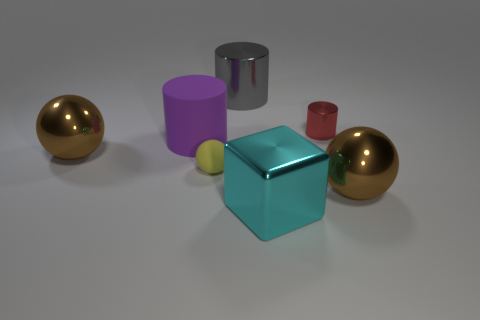There is a shiny object that is right of the tiny cylinder; is its shape the same as the large purple matte object?
Offer a terse response. No. What size is the rubber sphere that is in front of the red metallic thing right of the gray metallic cylinder?
Ensure brevity in your answer.  Small. There is a cylinder that is the same material as the big gray thing; what is its color?
Your answer should be very brief. Red. How many cyan objects have the same size as the gray metal cylinder?
Keep it short and to the point. 1. What number of blue things are cubes or rubber cylinders?
Ensure brevity in your answer.  0. How many things are either cubes or metallic objects on the left side of the big cyan thing?
Keep it short and to the point. 3. There is a big cylinder to the left of the tiny yellow matte sphere; what material is it?
Offer a terse response. Rubber. What is the shape of the thing that is the same size as the yellow sphere?
Give a very brief answer. Cylinder. Are there any green metal things that have the same shape as the tiny yellow thing?
Keep it short and to the point. No. Are the cyan block and the purple thing left of the big cyan cube made of the same material?
Offer a terse response. No. 